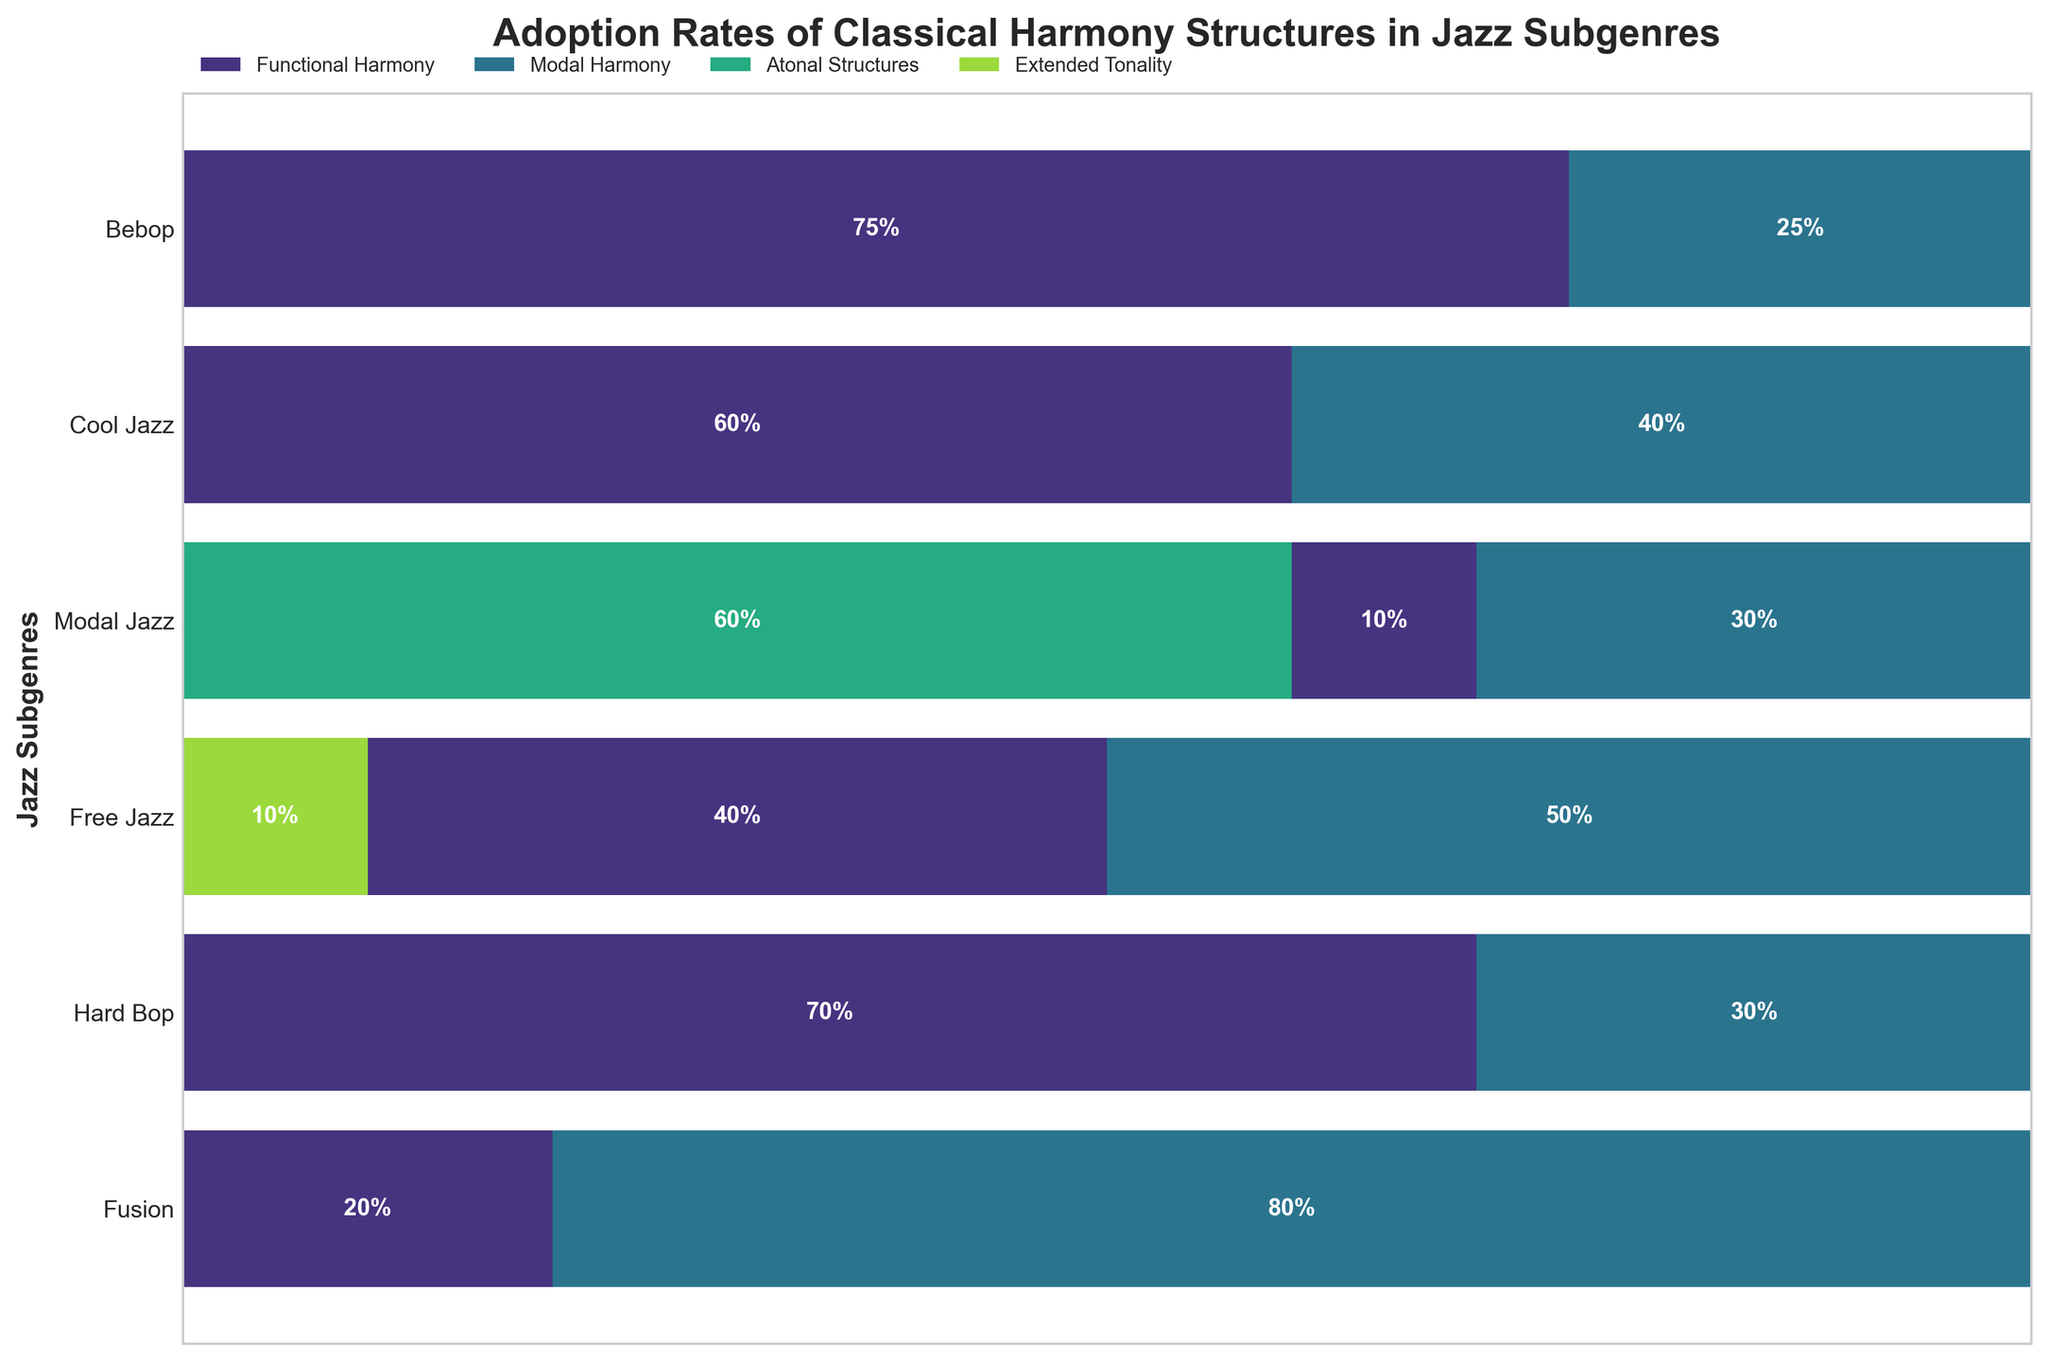What's the title of the plot? The title of the plot is usually displayed at the top of the figure, indicating what it represents. In this case, it is "Adoption Rates of Classical Harmony Structures in Jazz Subgenres".
Answer: Adoption Rates of Classical Harmony Structures in Jazz Subgenres Which jazz subgenre has the highest adoption rate of Modal Harmony? From the plot, Modal Jazz has the largest segment for Modal Harmony, indicating it has the highest adoption rate of this structure.
Answer: Modal Jazz What is the total adoption rate percentage of Functional Harmony across all subgenres? To find the total adoption rate percentage, sum the heights of the Functional Harmony segments across all subgenres: Bebop (75) + Cool Jazz (60) + Modal Jazz (20) + Free Jazz (10) + Hard Bop (70) + Fusion (40) = 275%.
Answer: 275% How does the adoption rate of Atonal Structures in Free Jazz compare to the highest adoption rate of any structure in any subgenre? The adoption rate of Atonal Structures in Free Jazz is 60%. The highest adoption rate of any structure is Modal Harmony in Modal Jazz at 80%. So, Atonal Structures in Free Jazz is less by 20%.
Answer: 20% less Which harmony structure has the least variation in adoption rates across subgenres? Examination of the width of each segment for all subgenres shows that Extended Tonality and Atonal Structures appear in very few subgenres. Extended Tonality appears only in Fusion with a fixed adoption rate of 10%.
Answer: Extended Tonality In which subgenre(s) do Modal Harmony and Functional Harmony have the same adoption rate? Locate the segments for both Modal Harmony and Functional Harmony and compare their widths. They are both 30% in Hard Bop.
Answer: Hard Bop What is the combined adoption rate of all classical structures in Fusion? Adding the adoption rates of Functional Harmony (40%), Modal Harmony (50%), and Extended Tonality (10%) in Fusion subgenre: 40 + 50 + 10 = 100%.
Answer: 100% Which subgenre shows the most diverse use of classical harmony structures? Diversity is reflected in the number of different structures used. Free Jazz utilizes Functional Harmony, Modal Harmony, and Atonal Structures. No other subgenre uses more than two structures.
Answer: Free Jazz What's the difference in adoption rates between Functional Harmony in Bebop and Modal Harmony in Cool Jazz? Functional Harmony in Bebop is 75% and Modal Harmony in Cool Jazz is 40%. The difference is 75 - 40 = 35%.
Answer: 35% How does the adoption rate of Functional Harmony in Modal Jazz compare to the adoption rate of Modal Harmony in the same subgenre? Compare the two segments in Modal Jazz. Functional Harmony is 20%, and Modal Harmony is 80%, showing Modal Harmony is 60% higher.
Answer: 60% higher 